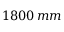Convert formula to latex. <formula><loc_0><loc_0><loc_500><loc_500>1 8 0 0 \, m m</formula> 